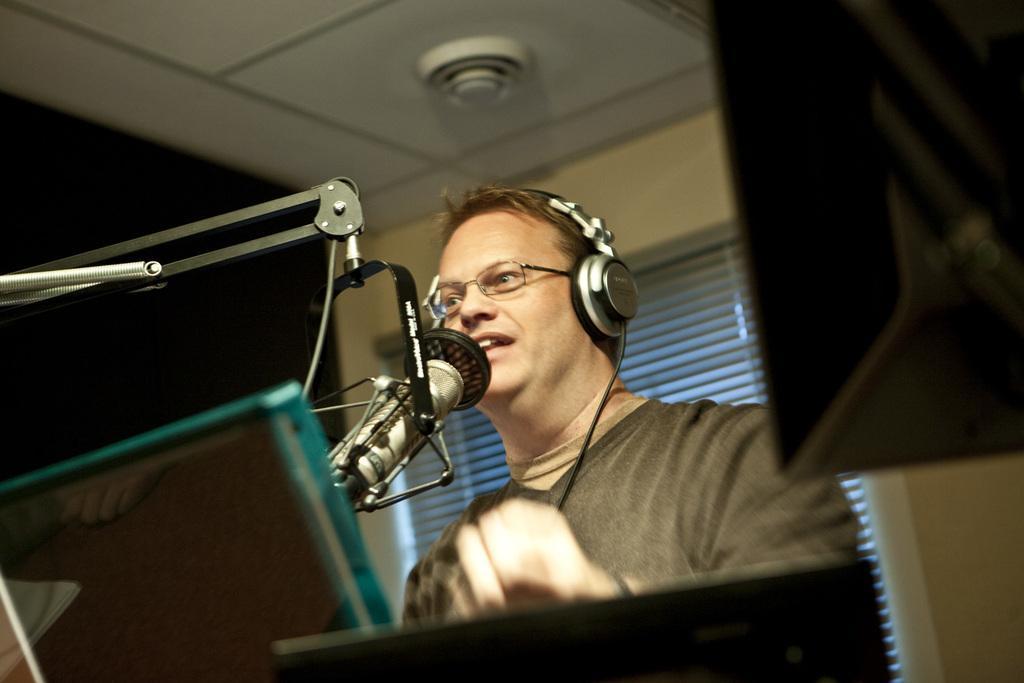Please provide a concise description of this image. In this image I can see a person wearing brown shirt singing in front of the microphone. Background I can see a sliding door and a wall in cream color. 